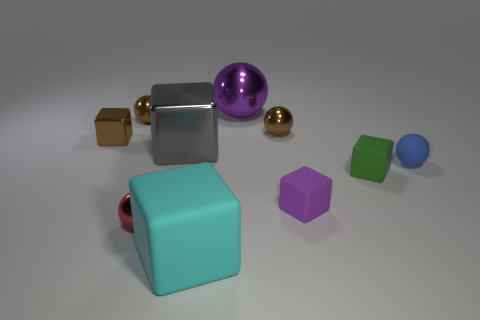Subtract all small metallic balls. How many balls are left? 2 Subtract all purple balls. How many balls are left? 4 Subtract 4 cubes. How many cubes are left? 1 Add 4 big gray blocks. How many big gray blocks are left? 5 Add 7 small yellow shiny blocks. How many small yellow shiny blocks exist? 7 Subtract 1 blue spheres. How many objects are left? 9 Subtract all purple cubes. Subtract all gray cylinders. How many cubes are left? 4 Subtract all red cylinders. How many green blocks are left? 1 Subtract all tiny blue objects. Subtract all purple shiny objects. How many objects are left? 8 